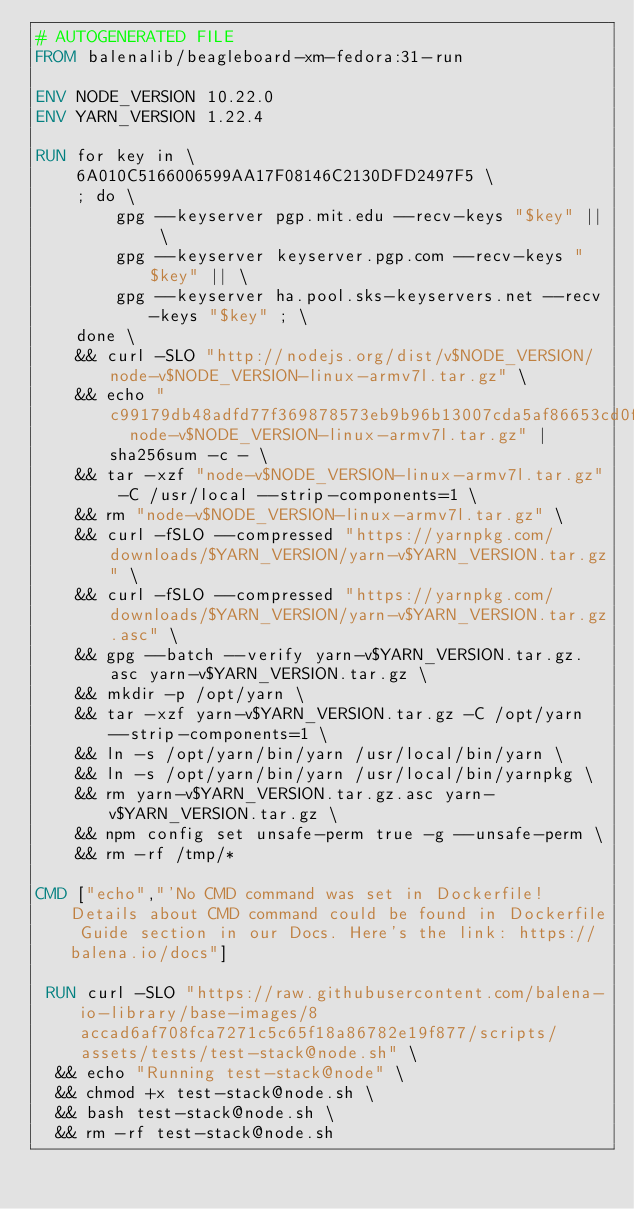<code> <loc_0><loc_0><loc_500><loc_500><_Dockerfile_># AUTOGENERATED FILE
FROM balenalib/beagleboard-xm-fedora:31-run

ENV NODE_VERSION 10.22.0
ENV YARN_VERSION 1.22.4

RUN for key in \
	6A010C5166006599AA17F08146C2130DFD2497F5 \
	; do \
		gpg --keyserver pgp.mit.edu --recv-keys "$key" || \
		gpg --keyserver keyserver.pgp.com --recv-keys "$key" || \
		gpg --keyserver ha.pool.sks-keyservers.net --recv-keys "$key" ; \
	done \
	&& curl -SLO "http://nodejs.org/dist/v$NODE_VERSION/node-v$NODE_VERSION-linux-armv7l.tar.gz" \
	&& echo "c99179db48adfd77f369878573eb9b96b13007cda5af86653cd0f5a8d772fc90  node-v$NODE_VERSION-linux-armv7l.tar.gz" | sha256sum -c - \
	&& tar -xzf "node-v$NODE_VERSION-linux-armv7l.tar.gz" -C /usr/local --strip-components=1 \
	&& rm "node-v$NODE_VERSION-linux-armv7l.tar.gz" \
	&& curl -fSLO --compressed "https://yarnpkg.com/downloads/$YARN_VERSION/yarn-v$YARN_VERSION.tar.gz" \
	&& curl -fSLO --compressed "https://yarnpkg.com/downloads/$YARN_VERSION/yarn-v$YARN_VERSION.tar.gz.asc" \
	&& gpg --batch --verify yarn-v$YARN_VERSION.tar.gz.asc yarn-v$YARN_VERSION.tar.gz \
	&& mkdir -p /opt/yarn \
	&& tar -xzf yarn-v$YARN_VERSION.tar.gz -C /opt/yarn --strip-components=1 \
	&& ln -s /opt/yarn/bin/yarn /usr/local/bin/yarn \
	&& ln -s /opt/yarn/bin/yarn /usr/local/bin/yarnpkg \
	&& rm yarn-v$YARN_VERSION.tar.gz.asc yarn-v$YARN_VERSION.tar.gz \
	&& npm config set unsafe-perm true -g --unsafe-perm \
	&& rm -rf /tmp/*

CMD ["echo","'No CMD command was set in Dockerfile! Details about CMD command could be found in Dockerfile Guide section in our Docs. Here's the link: https://balena.io/docs"]

 RUN curl -SLO "https://raw.githubusercontent.com/balena-io-library/base-images/8accad6af708fca7271c5c65f18a86782e19f877/scripts/assets/tests/test-stack@node.sh" \
  && echo "Running test-stack@node" \
  && chmod +x test-stack@node.sh \
  && bash test-stack@node.sh \
  && rm -rf test-stack@node.sh 
</code> 